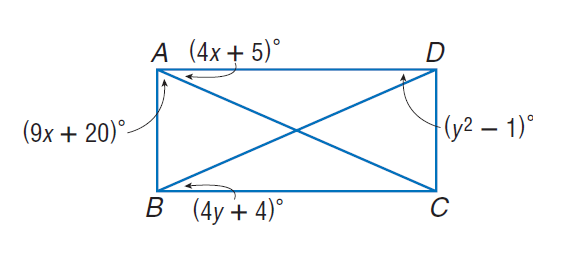Answer the mathemtical geometry problem and directly provide the correct option letter.
Question: Quadrilateral A B C D is a rectangle. Find x.
Choices: A: 5 B: 10 C: 20 D: 25 A 